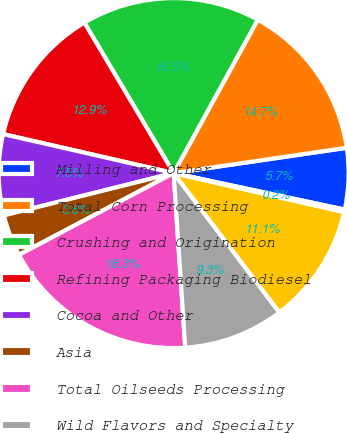Convert chart. <chart><loc_0><loc_0><loc_500><loc_500><pie_chart><fcel>Milling and Other<fcel>Total Corn Processing<fcel>Crushing and Origination<fcel>Refining Packaging Biodiesel<fcel>Cocoa and Other<fcel>Asia<fcel>Total Oilseeds Processing<fcel>Wild Flavors and Specialty<fcel>Total Wild Flavors and<fcel>Other - Financial<nl><fcel>5.66%<fcel>14.71%<fcel>16.51%<fcel>12.9%<fcel>7.47%<fcel>3.85%<fcel>18.32%<fcel>9.28%<fcel>11.09%<fcel>0.23%<nl></chart> 